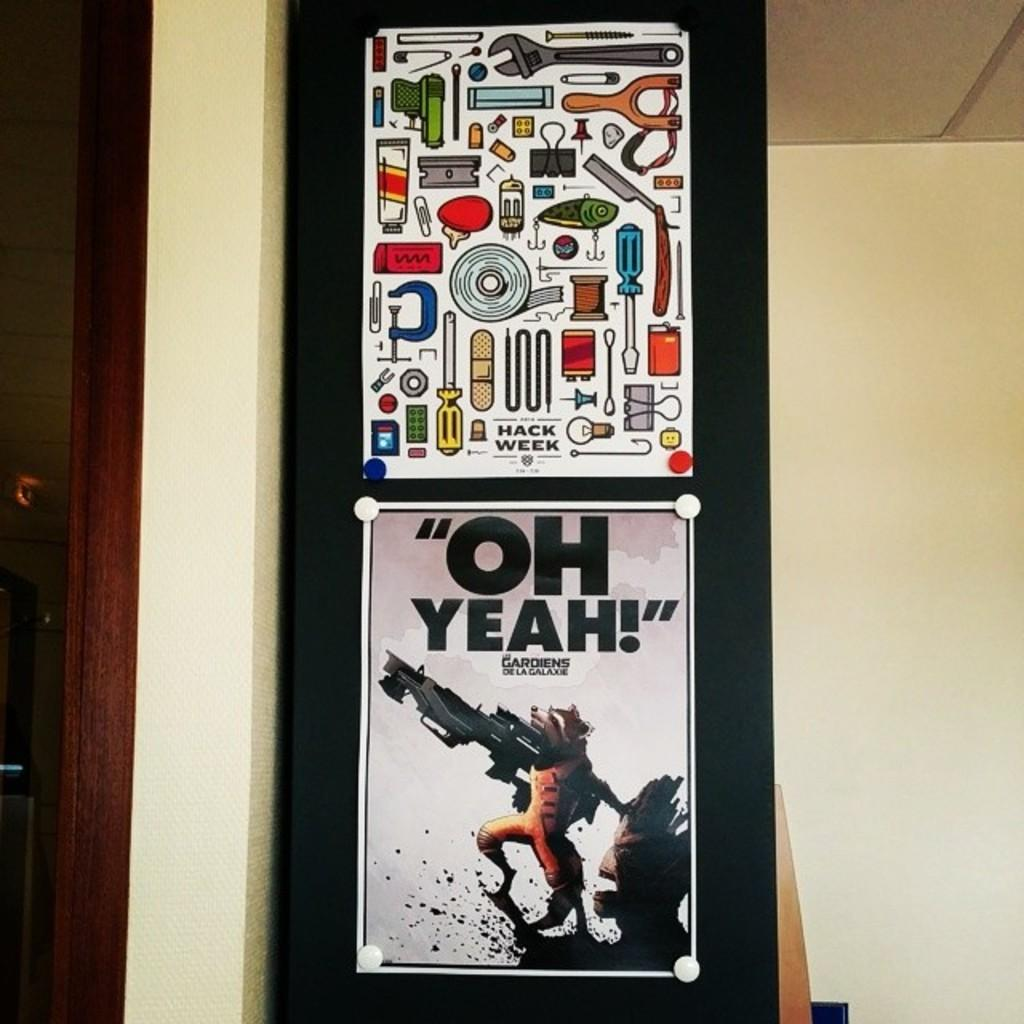Provide a one-sentence caption for the provided image. A poster with cartoons of tools is hung above a poster with the raccoon from Guardians of the Galaxy. 